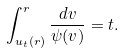<formula> <loc_0><loc_0><loc_500><loc_500>\int ^ { r } _ { u _ { t } ( r ) } \frac { d v } { { \psi } ( v ) } = t .</formula> 